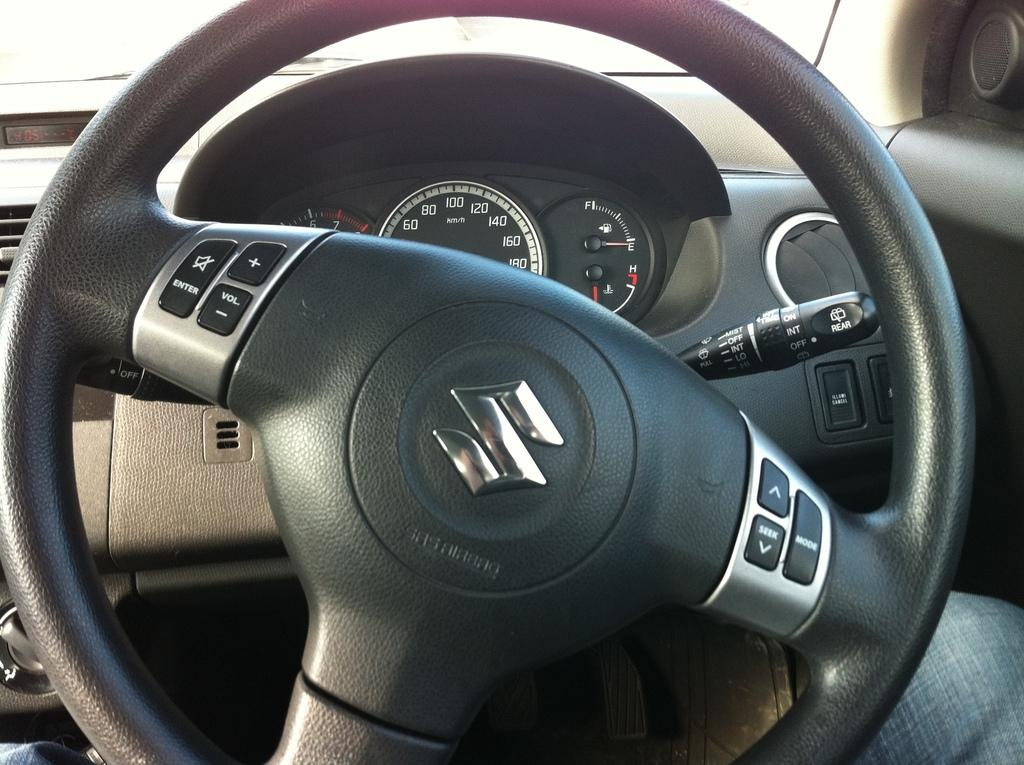What is the main object in the image? The image contains a steering wheel. What instrument is used to measure speed in the image? There is a speedometer in the image. What other controls are present in the image? There are other control buttons in the image. What type of health advice can be seen on the recess in the image? There is no recess or health advice present in the image; it contains a steering wheel, a speedometer, and other control buttons. 